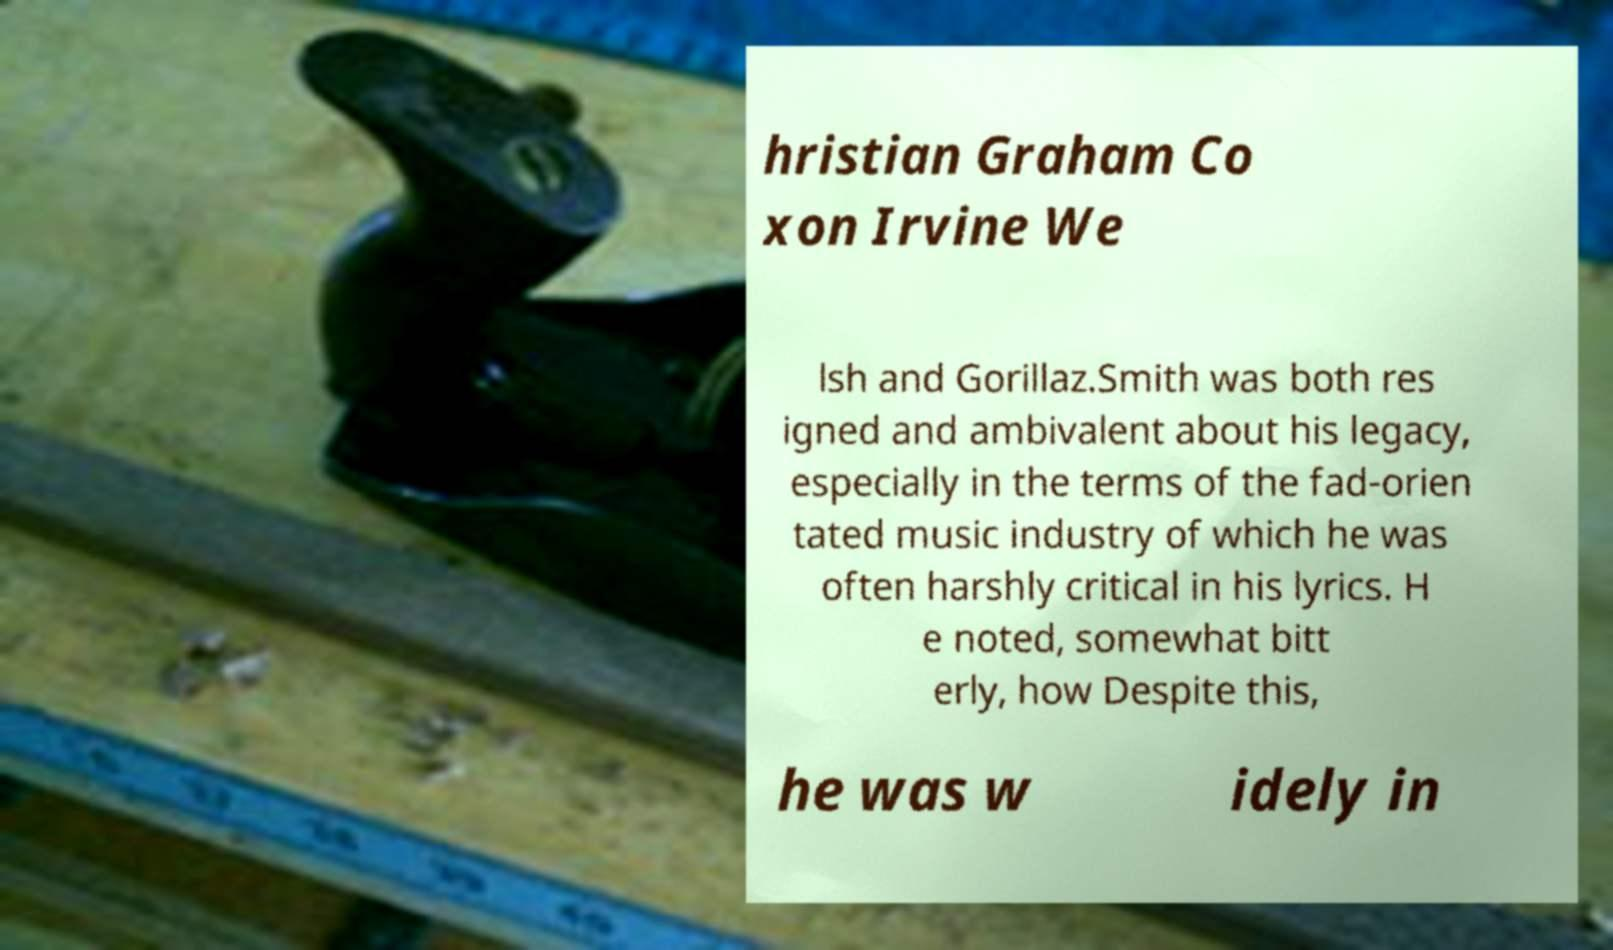Could you assist in decoding the text presented in this image and type it out clearly? hristian Graham Co xon Irvine We lsh and Gorillaz.Smith was both res igned and ambivalent about his legacy, especially in the terms of the fad-orien tated music industry of which he was often harshly critical in his lyrics. H e noted, somewhat bitt erly, how Despite this, he was w idely in 